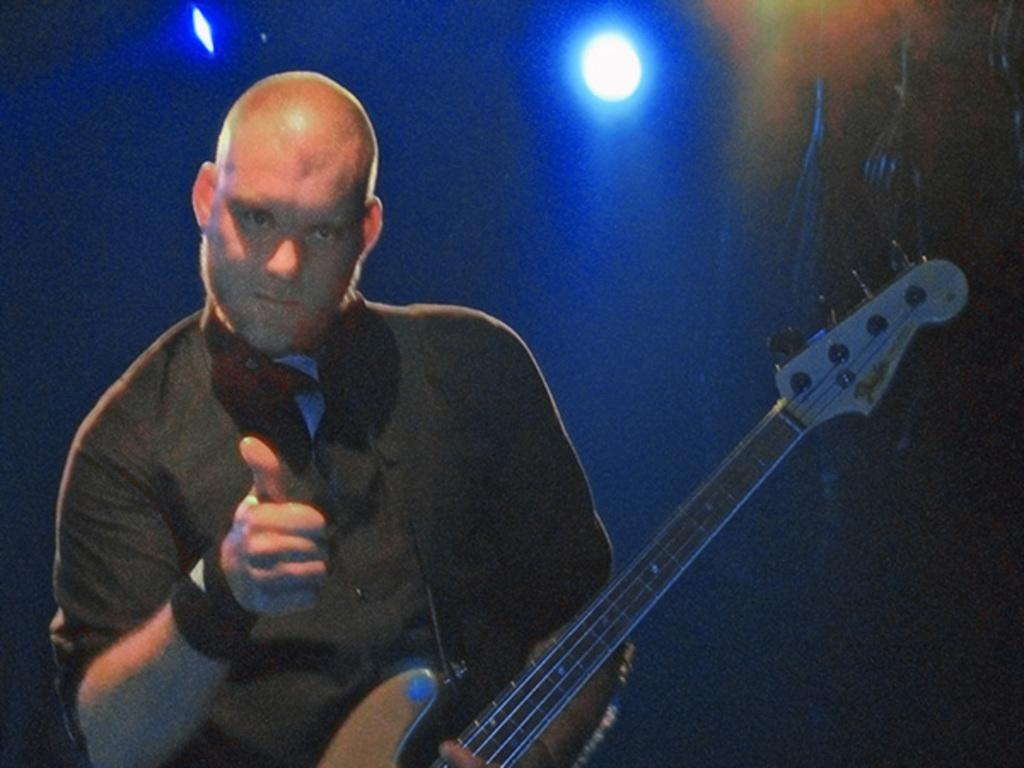What is the man in the image doing? The man is indicating a sign and holding a guitar. What is the man wearing in the image? The man is wearing a black color shirt. What can be seen in the background of the image? There is a light in the background of the image, and the background is in blue color. Can you see any spots on the man's shirt in the image? There is no mention of spots on the man's shirt in the provided facts, so we cannot determine if any are present. Is there a fire visible in the image? There is no mention of a fire in the provided facts, so we cannot determine if one is present. 